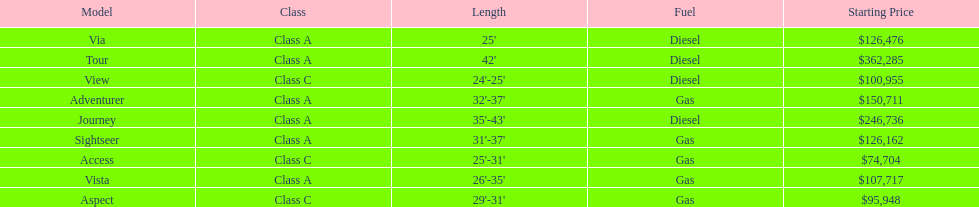Is the vista more than the aspect? Yes. 